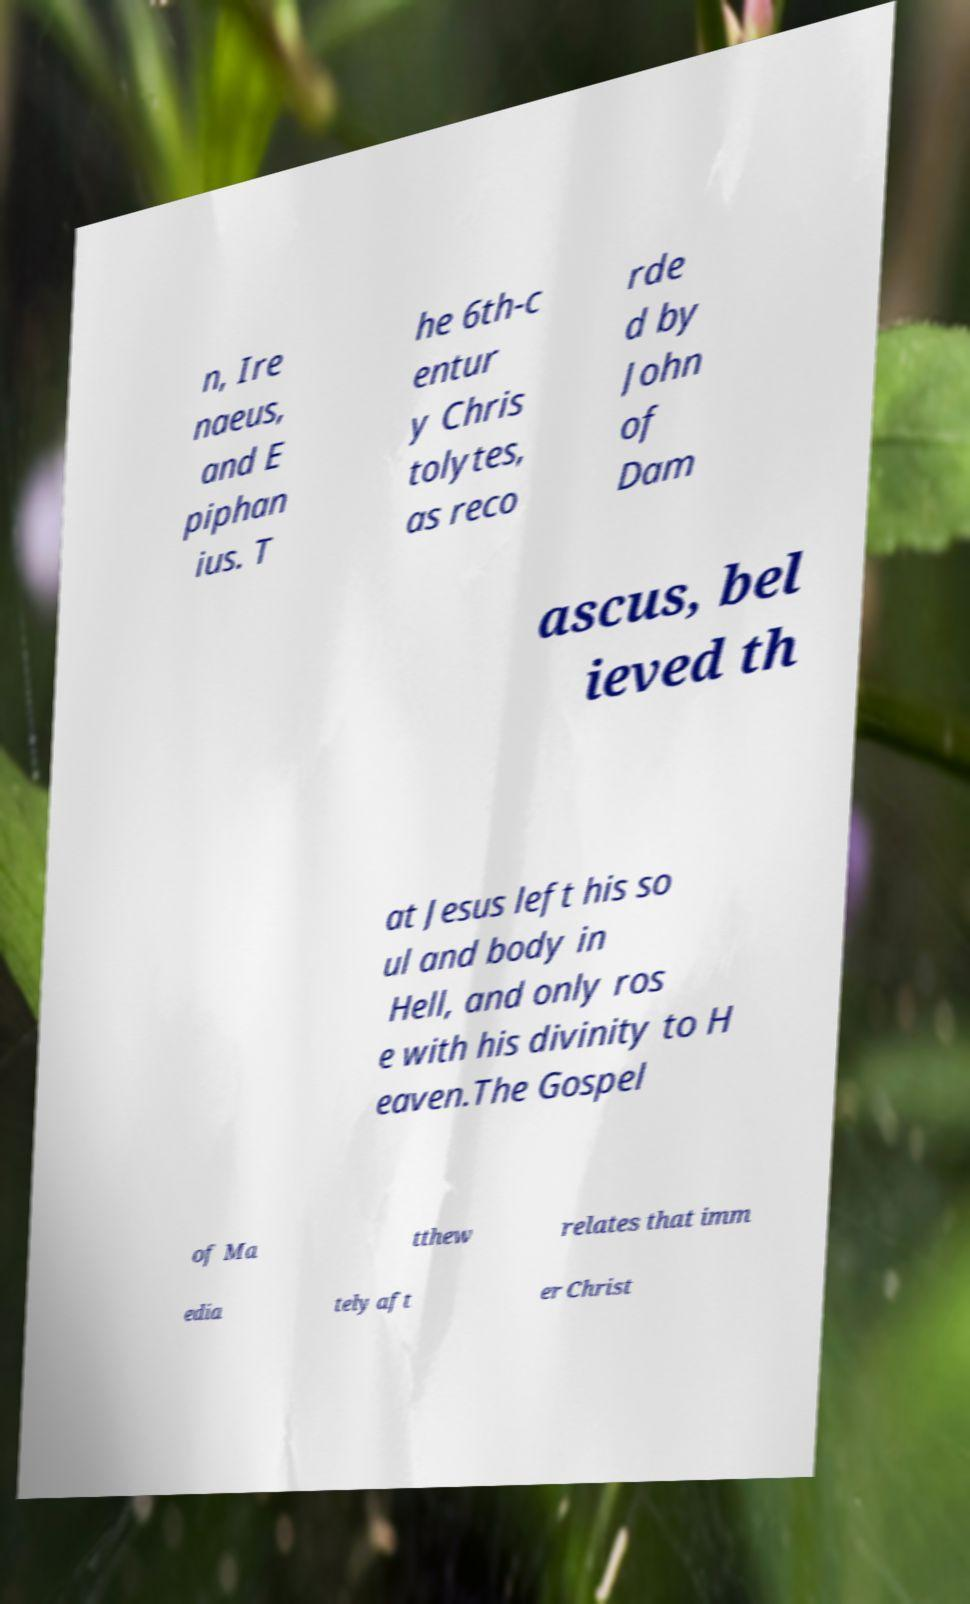Please identify and transcribe the text found in this image. n, Ire naeus, and E piphan ius. T he 6th-c entur y Chris tolytes, as reco rde d by John of Dam ascus, bel ieved th at Jesus left his so ul and body in Hell, and only ros e with his divinity to H eaven.The Gospel of Ma tthew relates that imm edia tely aft er Christ 